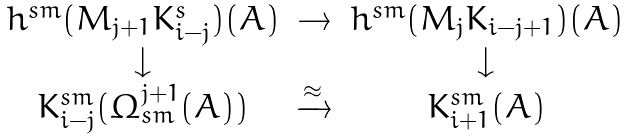Convert formula to latex. <formula><loc_0><loc_0><loc_500><loc_500>\begin{array} { c c c } h ^ { s m } ( M _ { j + 1 } K _ { i - j } ^ { s } ) ( A ) & \rightarrow & h ^ { s m } ( M _ { j } K _ { i - j + 1 } ) ( A ) \\ \downarrow & & \downarrow \\ K _ { i - j } ^ { s m } ( \Omega _ { s m } ^ { j + 1 } ( A ) ) & \xrightarrow { \approx } & K _ { i + 1 } ^ { s m } ( A ) \\ \end{array}</formula> 